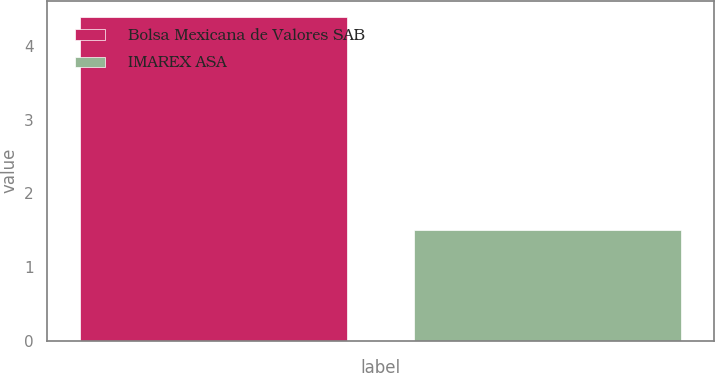<chart> <loc_0><loc_0><loc_500><loc_500><bar_chart><fcel>Bolsa Mexicana de Valores SAB<fcel>IMAREX ASA<nl><fcel>4.4<fcel>1.5<nl></chart> 